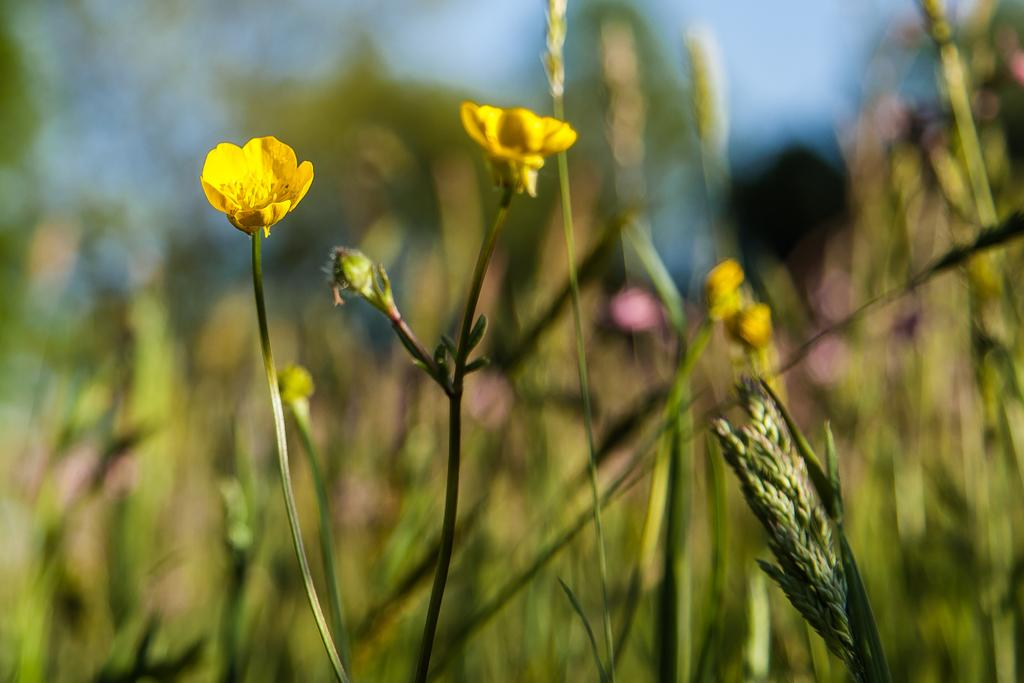What type of plants can be seen in the foreground of the image? There are flower plants in the foreground of the image. What stage of growth are the plants in? There are buds in the foreground of the image, indicating that the plants are in an early stage of growth. Can you describe the background of the image? The background of the image is blurry. What committee is responsible for the acoustics in the image? There is no committee or acoustics mentioned in the image; it features flower plants and buds in the foreground and a blurry background. 